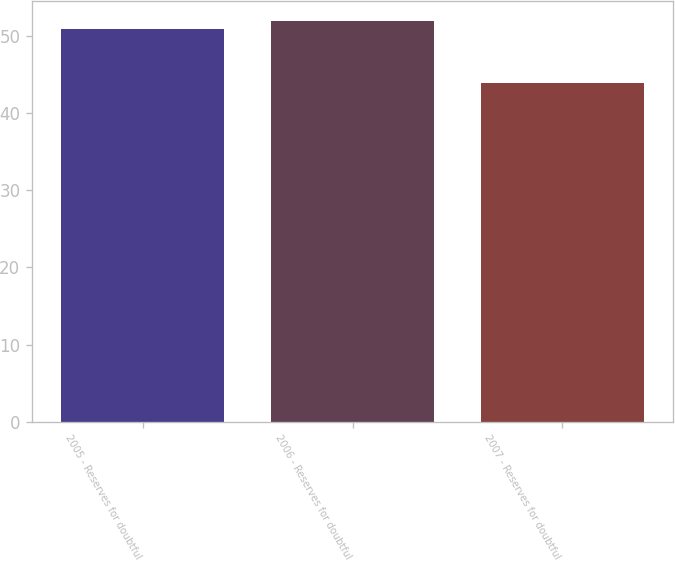<chart> <loc_0><loc_0><loc_500><loc_500><bar_chart><fcel>2005 - Reserves for doubtful<fcel>2006 - Reserves for doubtful<fcel>2007 - Reserves for doubtful<nl><fcel>51<fcel>52<fcel>44<nl></chart> 